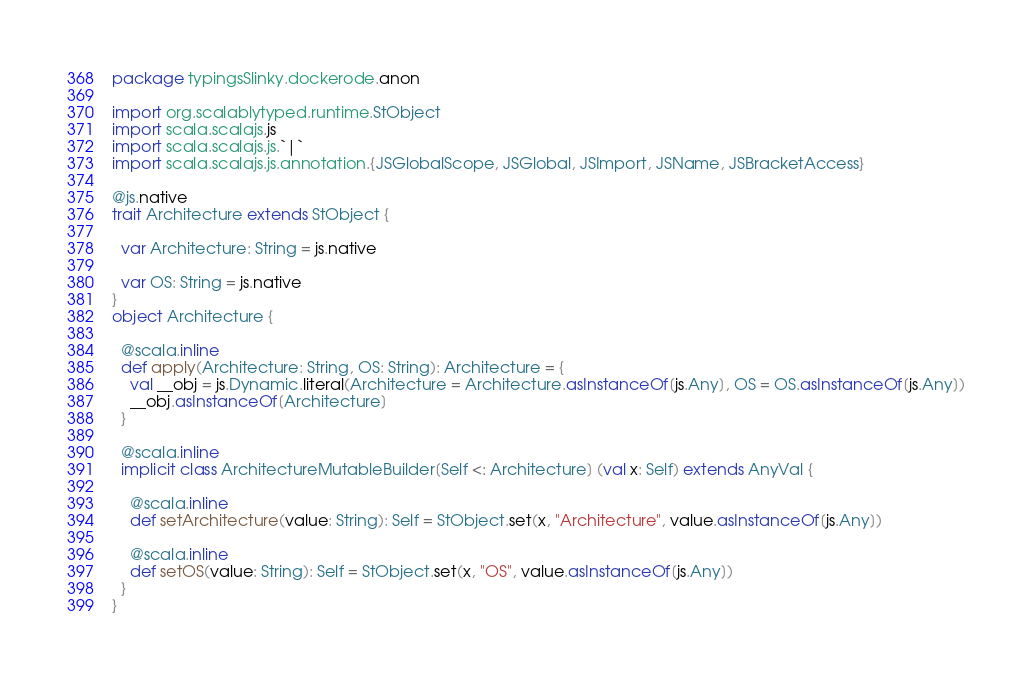<code> <loc_0><loc_0><loc_500><loc_500><_Scala_>package typingsSlinky.dockerode.anon

import org.scalablytyped.runtime.StObject
import scala.scalajs.js
import scala.scalajs.js.`|`
import scala.scalajs.js.annotation.{JSGlobalScope, JSGlobal, JSImport, JSName, JSBracketAccess}

@js.native
trait Architecture extends StObject {
  
  var Architecture: String = js.native
  
  var OS: String = js.native
}
object Architecture {
  
  @scala.inline
  def apply(Architecture: String, OS: String): Architecture = {
    val __obj = js.Dynamic.literal(Architecture = Architecture.asInstanceOf[js.Any], OS = OS.asInstanceOf[js.Any])
    __obj.asInstanceOf[Architecture]
  }
  
  @scala.inline
  implicit class ArchitectureMutableBuilder[Self <: Architecture] (val x: Self) extends AnyVal {
    
    @scala.inline
    def setArchitecture(value: String): Self = StObject.set(x, "Architecture", value.asInstanceOf[js.Any])
    
    @scala.inline
    def setOS(value: String): Self = StObject.set(x, "OS", value.asInstanceOf[js.Any])
  }
}
</code> 